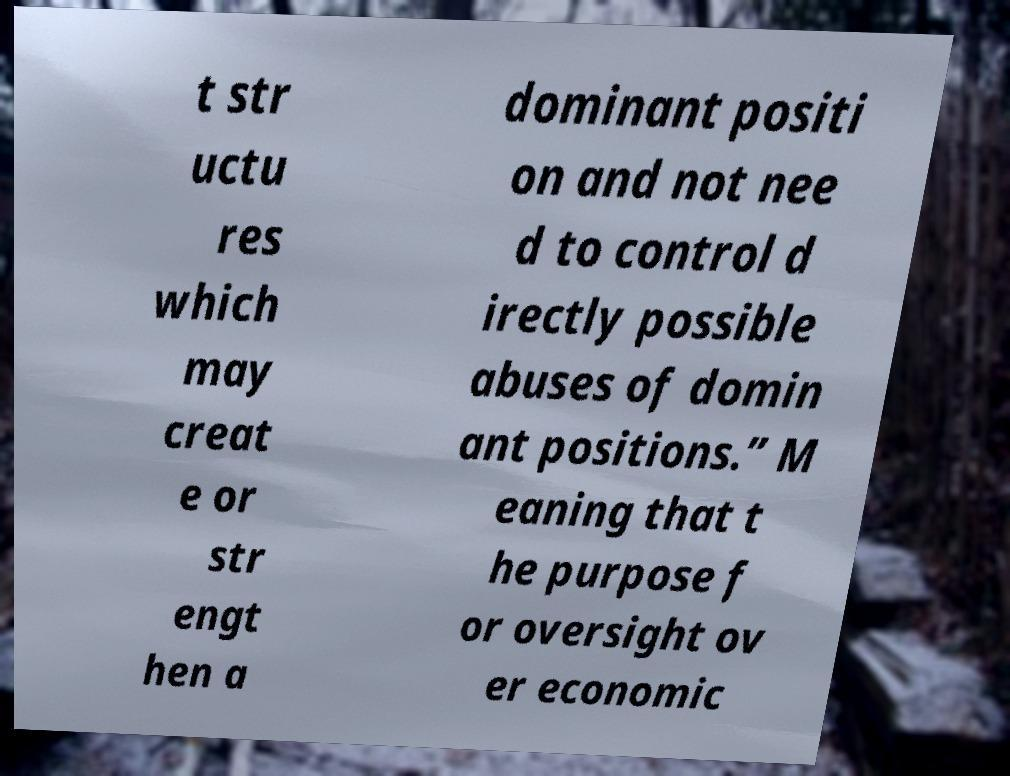Can you read and provide the text displayed in the image?This photo seems to have some interesting text. Can you extract and type it out for me? t str uctu res which may creat e or str engt hen a dominant positi on and not nee d to control d irectly possible abuses of domin ant positions.” M eaning that t he purpose f or oversight ov er economic 